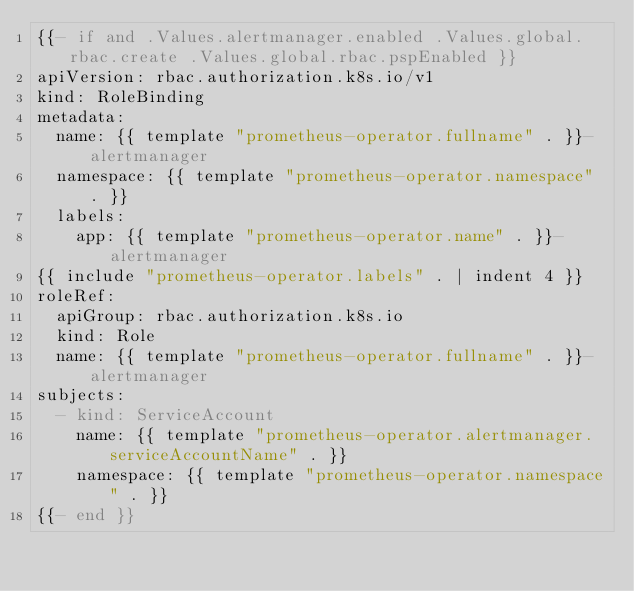Convert code to text. <code><loc_0><loc_0><loc_500><loc_500><_YAML_>{{- if and .Values.alertmanager.enabled .Values.global.rbac.create .Values.global.rbac.pspEnabled }}
apiVersion: rbac.authorization.k8s.io/v1
kind: RoleBinding
metadata:
  name: {{ template "prometheus-operator.fullname" . }}-alertmanager
  namespace: {{ template "prometheus-operator.namespace" . }}
  labels:
    app: {{ template "prometheus-operator.name" . }}-alertmanager
{{ include "prometheus-operator.labels" . | indent 4 }}
roleRef:
  apiGroup: rbac.authorization.k8s.io
  kind: Role
  name: {{ template "prometheus-operator.fullname" . }}-alertmanager
subjects:
  - kind: ServiceAccount
    name: {{ template "prometheus-operator.alertmanager.serviceAccountName" . }}
    namespace: {{ template "prometheus-operator.namespace" . }}
{{- end }}
</code> 